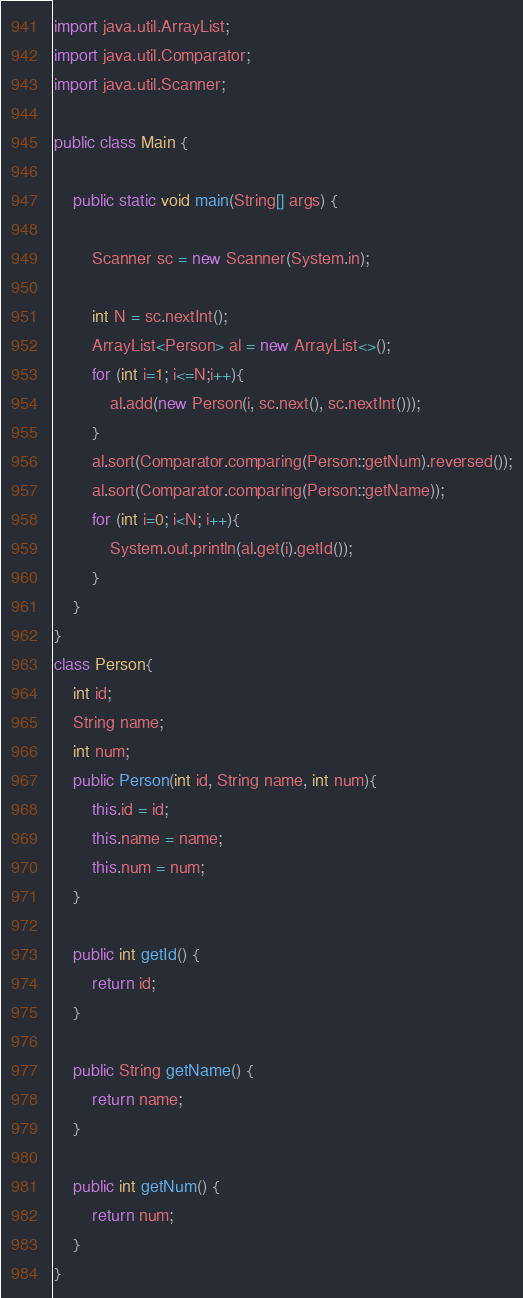Convert code to text. <code><loc_0><loc_0><loc_500><loc_500><_Java_>import java.util.ArrayList;
import java.util.Comparator;
import java.util.Scanner;

public class Main {

    public static void main(String[] args) {

        Scanner sc = new Scanner(System.in);

        int N = sc.nextInt();
        ArrayList<Person> al = new ArrayList<>();
        for (int i=1; i<=N;i++){
            al.add(new Person(i, sc.next(), sc.nextInt()));
        }
        al.sort(Comparator.comparing(Person::getNum).reversed());
        al.sort(Comparator.comparing(Person::getName));
        for (int i=0; i<N; i++){
            System.out.println(al.get(i).getId());
        }
    }
}
class Person{
    int id;
    String name;
    int num;
    public Person(int id, String name, int num){
        this.id = id;
        this.name = name;
        this.num = num;
    }

    public int getId() {
        return id;
    }

    public String getName() {
        return name;
    }

    public int getNum() {
        return num;
    }
}
</code> 